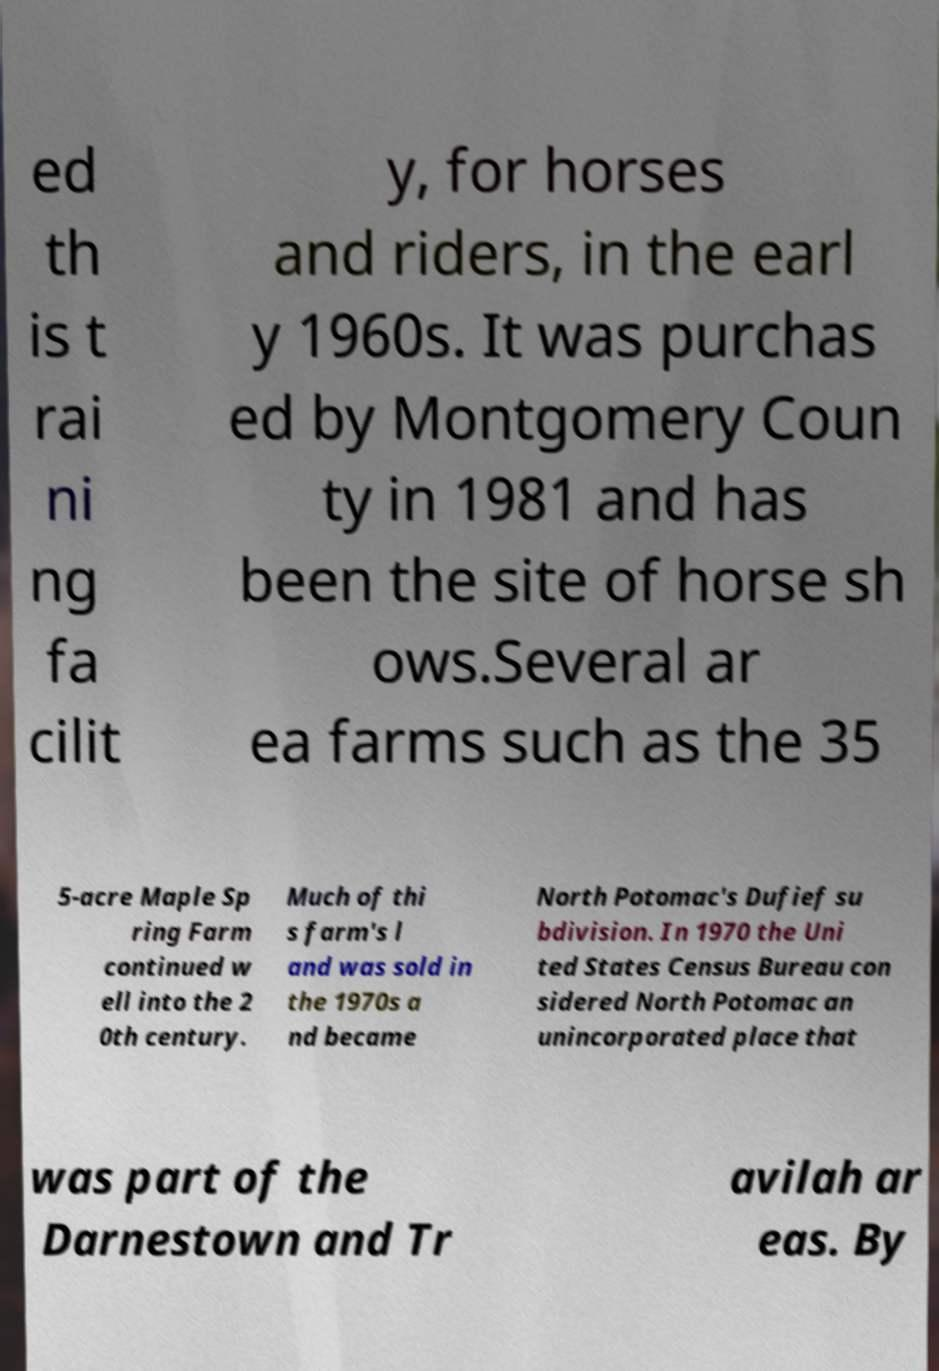Could you assist in decoding the text presented in this image and type it out clearly? ed th is t rai ni ng fa cilit y, for horses and riders, in the earl y 1960s. It was purchas ed by Montgomery Coun ty in 1981 and has been the site of horse sh ows.Several ar ea farms such as the 35 5-acre Maple Sp ring Farm continued w ell into the 2 0th century. Much of thi s farm's l and was sold in the 1970s a nd became North Potomac's Dufief su bdivision. In 1970 the Uni ted States Census Bureau con sidered North Potomac an unincorporated place that was part of the Darnestown and Tr avilah ar eas. By 